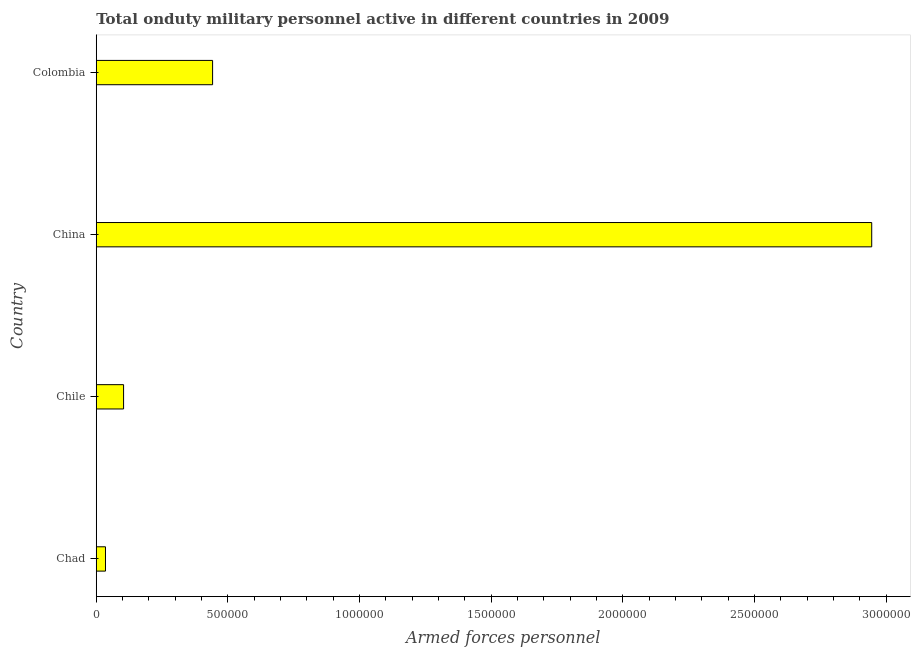Does the graph contain any zero values?
Offer a terse response. No. Does the graph contain grids?
Your answer should be very brief. No. What is the title of the graph?
Your answer should be compact. Total onduty military personnel active in different countries in 2009. What is the label or title of the X-axis?
Provide a succinct answer. Armed forces personnel. What is the number of armed forces personnel in Chile?
Make the answer very short. 1.04e+05. Across all countries, what is the maximum number of armed forces personnel?
Make the answer very short. 2.94e+06. Across all countries, what is the minimum number of armed forces personnel?
Ensure brevity in your answer.  3.50e+04. In which country was the number of armed forces personnel maximum?
Your response must be concise. China. In which country was the number of armed forces personnel minimum?
Ensure brevity in your answer.  Chad. What is the sum of the number of armed forces personnel?
Give a very brief answer. 3.53e+06. What is the difference between the number of armed forces personnel in Chad and Chile?
Keep it short and to the point. -6.87e+04. What is the average number of armed forces personnel per country?
Offer a very short reply. 8.81e+05. What is the median number of armed forces personnel?
Your answer should be compact. 2.73e+05. What is the ratio of the number of armed forces personnel in Chile to that in Colombia?
Offer a terse response. 0.23. Is the difference between the number of armed forces personnel in Chad and Colombia greater than the difference between any two countries?
Keep it short and to the point. No. What is the difference between the highest and the second highest number of armed forces personnel?
Your answer should be very brief. 2.50e+06. What is the difference between the highest and the lowest number of armed forces personnel?
Give a very brief answer. 2.91e+06. How many countries are there in the graph?
Offer a terse response. 4. Are the values on the major ticks of X-axis written in scientific E-notation?
Provide a short and direct response. No. What is the Armed forces personnel in Chad?
Your response must be concise. 3.50e+04. What is the Armed forces personnel in Chile?
Your answer should be compact. 1.04e+05. What is the Armed forces personnel in China?
Provide a short and direct response. 2.94e+06. What is the Armed forces personnel in Colombia?
Provide a succinct answer. 4.42e+05. What is the difference between the Armed forces personnel in Chad and Chile?
Offer a terse response. -6.87e+04. What is the difference between the Armed forces personnel in Chad and China?
Your response must be concise. -2.91e+06. What is the difference between the Armed forces personnel in Chad and Colombia?
Make the answer very short. -4.07e+05. What is the difference between the Armed forces personnel in Chile and China?
Ensure brevity in your answer.  -2.84e+06. What is the difference between the Armed forces personnel in Chile and Colombia?
Your answer should be compact. -3.38e+05. What is the difference between the Armed forces personnel in China and Colombia?
Your answer should be very brief. 2.50e+06. What is the ratio of the Armed forces personnel in Chad to that in Chile?
Give a very brief answer. 0.34. What is the ratio of the Armed forces personnel in Chad to that in China?
Provide a succinct answer. 0.01. What is the ratio of the Armed forces personnel in Chad to that in Colombia?
Ensure brevity in your answer.  0.08. What is the ratio of the Armed forces personnel in Chile to that in China?
Give a very brief answer. 0.04. What is the ratio of the Armed forces personnel in Chile to that in Colombia?
Your response must be concise. 0.23. What is the ratio of the Armed forces personnel in China to that in Colombia?
Give a very brief answer. 6.67. 